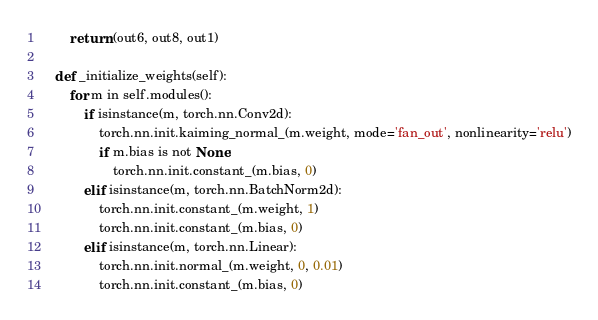<code> <loc_0><loc_0><loc_500><loc_500><_Python_>        return (out6, out8, out1)

    def _initialize_weights(self):
        for m in self.modules():
            if isinstance(m, torch.nn.Conv2d):
                torch.nn.init.kaiming_normal_(m.weight, mode='fan_out', nonlinearity='relu')
                if m.bias is not None:
                    torch.nn.init.constant_(m.bias, 0)
            elif isinstance(m, torch.nn.BatchNorm2d):
                torch.nn.init.constant_(m.weight, 1)
                torch.nn.init.constant_(m.bias, 0)
            elif isinstance(m, torch.nn.Linear):
                torch.nn.init.normal_(m.weight, 0, 0.01)
                torch.nn.init.constant_(m.bias, 0)
</code> 